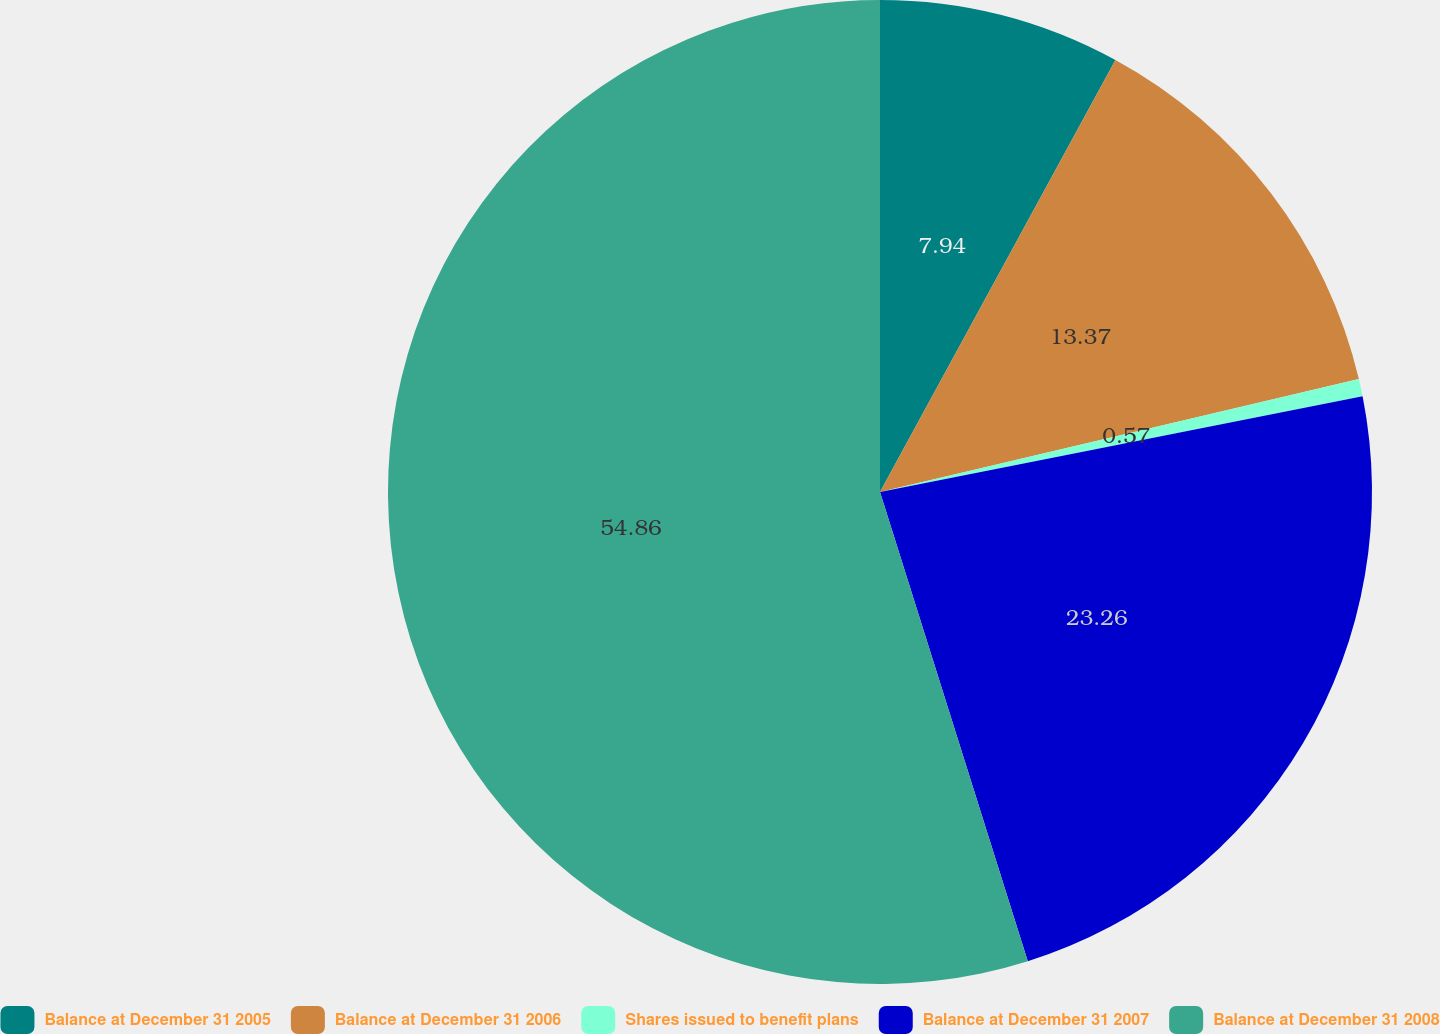Convert chart. <chart><loc_0><loc_0><loc_500><loc_500><pie_chart><fcel>Balance at December 31 2005<fcel>Balance at December 31 2006<fcel>Shares issued to benefit plans<fcel>Balance at December 31 2007<fcel>Balance at December 31 2008<nl><fcel>7.94%<fcel>13.37%<fcel>0.57%<fcel>23.26%<fcel>54.85%<nl></chart> 